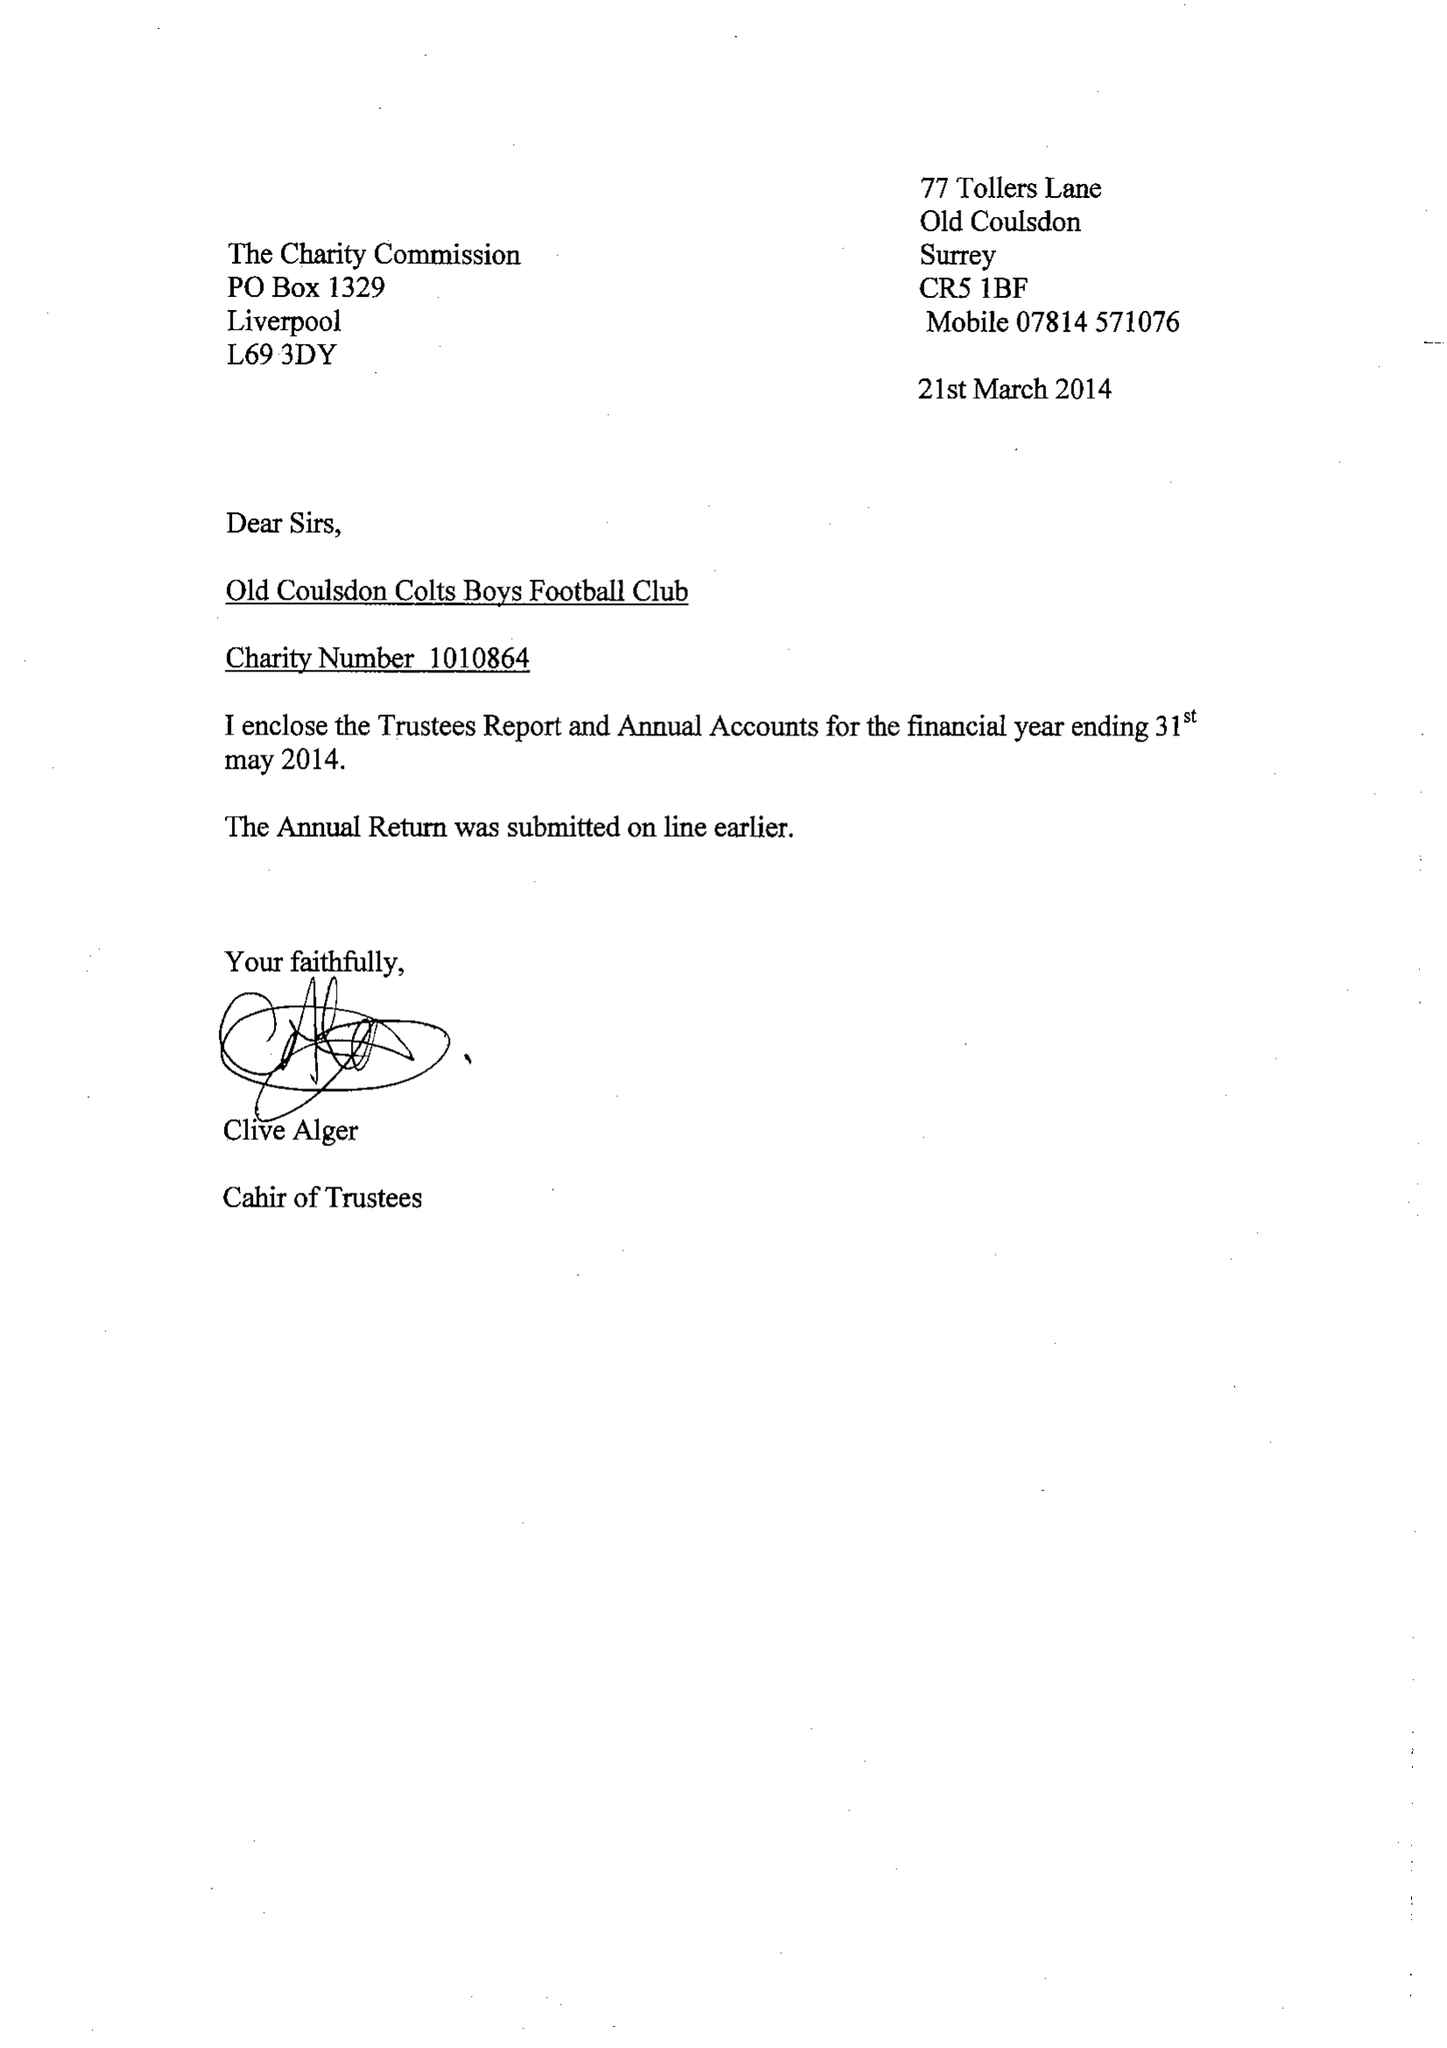What is the value for the charity_name?
Answer the question using a single word or phrase. Old Coulsdon Colts Boys Football Club 